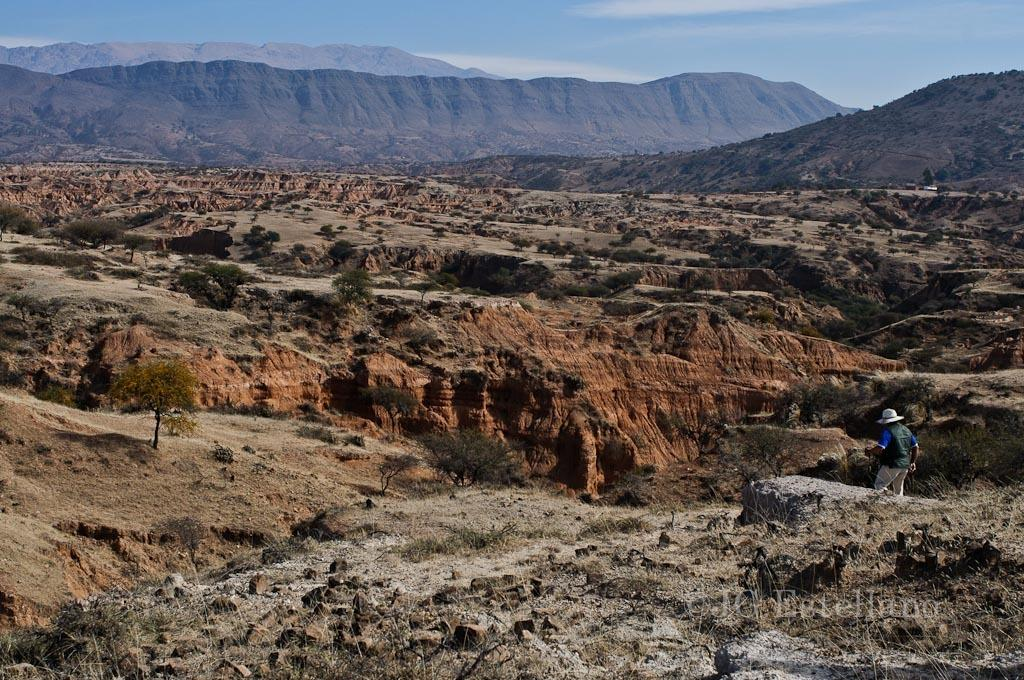What is the main subject of the image? There is a person in the image. What is the person wearing on their head? The person is wearing a hat. What is the person's posture in the image? The person is standing. What type of natural environment is visible in the image? There are trees and mountains in the image. What is visible at the top of the image? The sky is visible at the top of the image. Can you tell me how many yaks are grazing on the sheet in the image? There are no yaks or sheets present in the image. What type of motion is the person performing in the image? The provided facts do not mention any motion or action performed by the person in the image. 